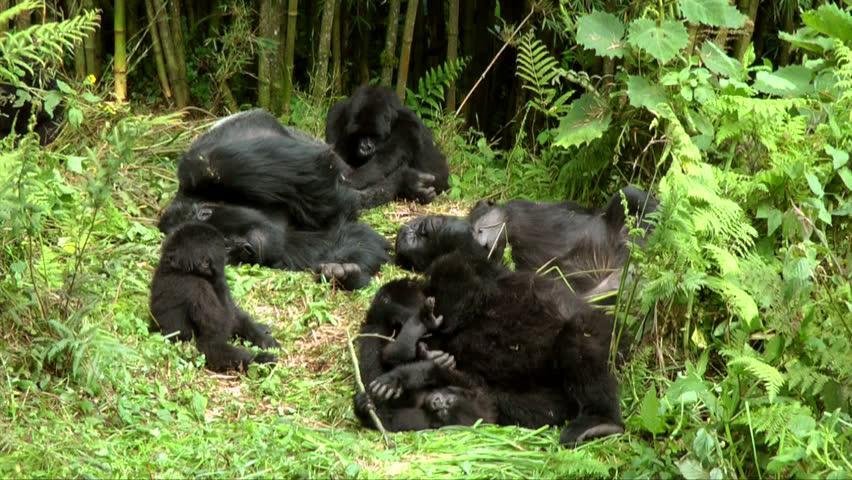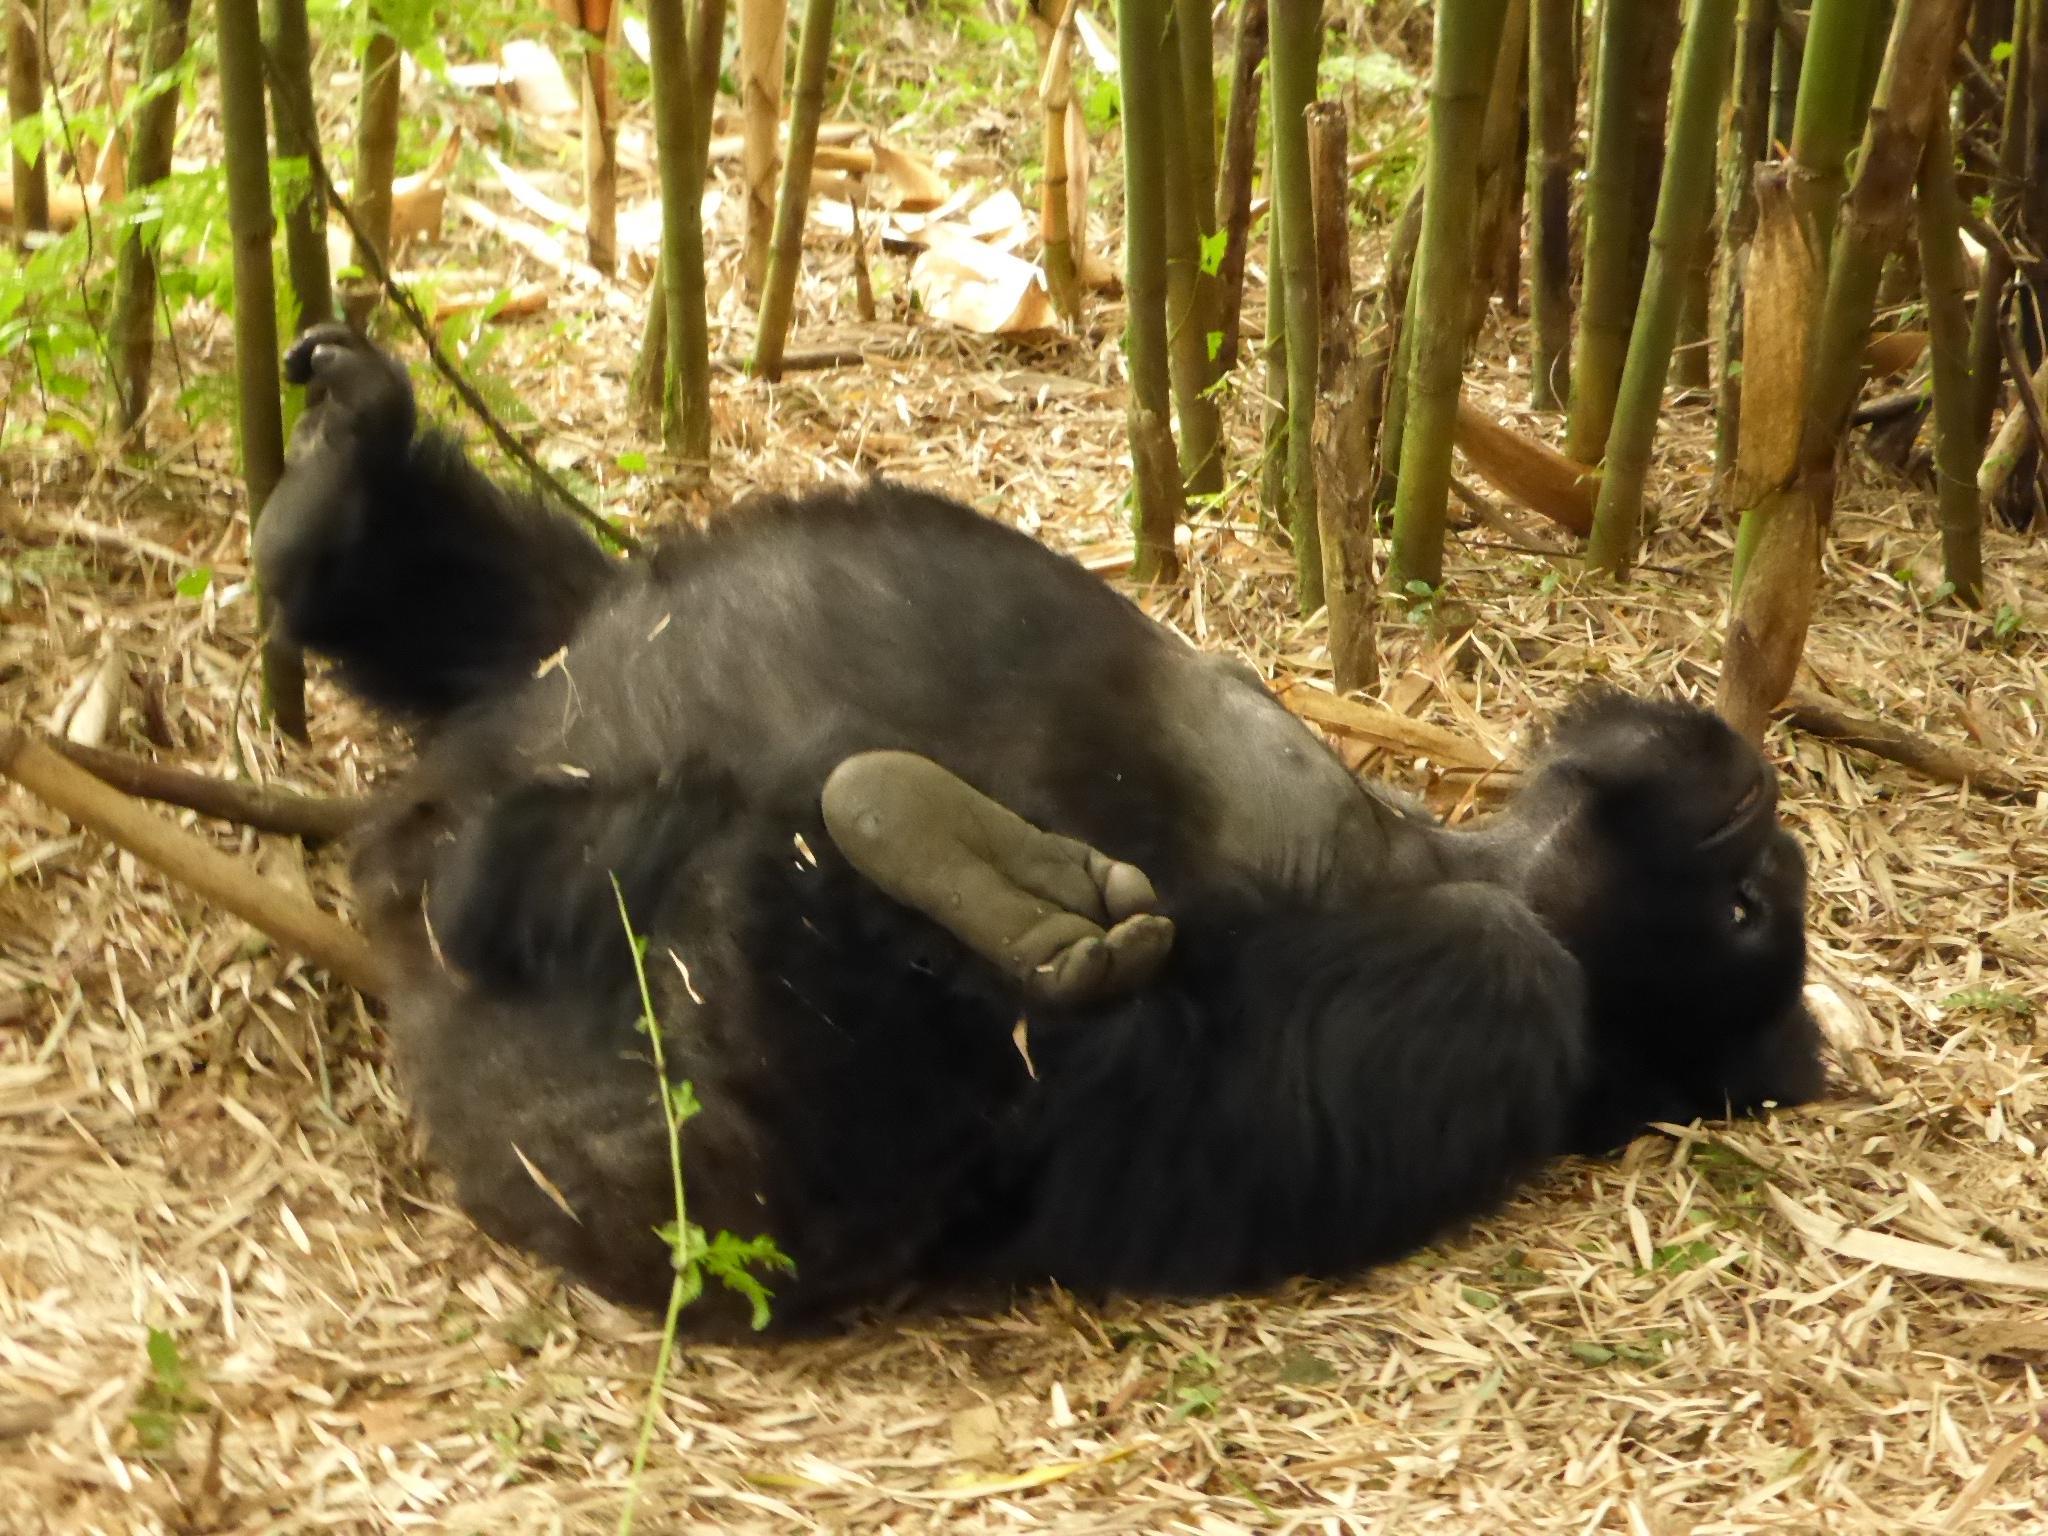The first image is the image on the left, the second image is the image on the right. Analyze the images presented: Is the assertion "The righthand image contains no more than two gorillas, including one with a big round belly." valid? Answer yes or no. Yes. The first image is the image on the left, the second image is the image on the right. Given the left and right images, does the statement "The right image contains no more than two gorillas." hold true? Answer yes or no. Yes. 